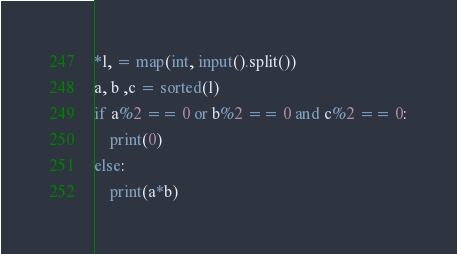<code> <loc_0><loc_0><loc_500><loc_500><_Python_>*l, = map(int, input().split())
a, b ,c = sorted(l)
if a%2 == 0 or b%2 == 0 and c%2 == 0:
    print(0)
else:
    print(a*b)</code> 